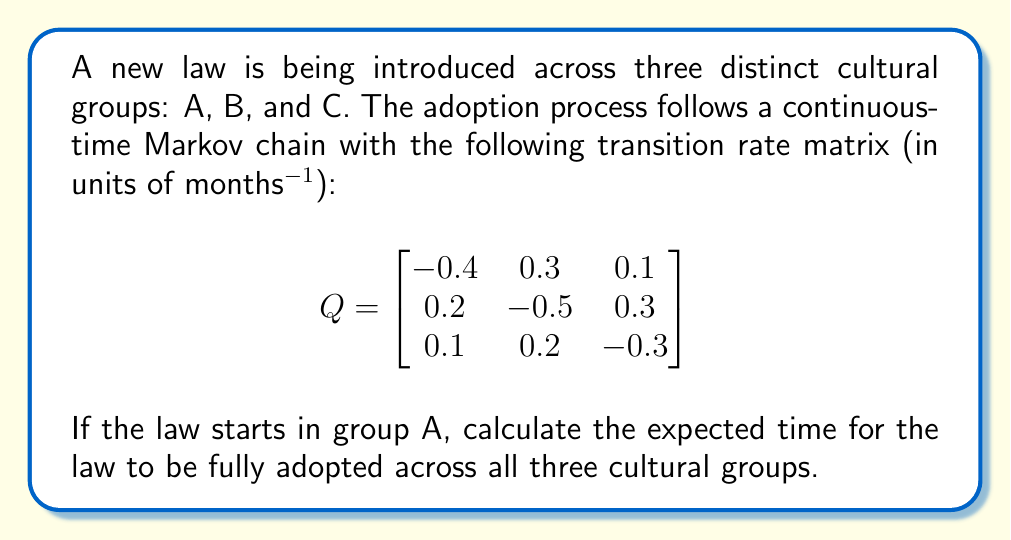Give your solution to this math problem. To solve this problem, we need to use the theory of absorbing Markov chains. The state where the law is fully adopted across all groups is an absorbing state, and we want to find the expected time to reach this state starting from group A.

Step 1: Identify the absorbing state.
The absorbing state is when the law is adopted by all groups, which is not explicitly represented in the given matrix. We need to add this state as a fourth state D.

Step 2: Modify the transition rate matrix to include the absorbing state.
$$Q' = \begin{bmatrix}
-0.4 & 0.3 & 0.1 & 0 \\
0.2 & -0.5 & 0.3 & 0 \\
0.1 & 0.2 & -0.3 & 0 \\
0 & 0 & 0 & 0
\end{bmatrix}$$

Step 3: Partition the matrix into submatrices.
$$Q' = \begin{bmatrix}
T & R \\
0 & 0
\end{bmatrix}$$

Where T is the 3x3 submatrix of transient states, and R is the 3x1 column vector of rates to the absorbing state.

Step 4: Calculate the fundamental matrix N.
$$N = -T^{-1}$$

Using a computer algebra system or matrix inversion method:

$$N = \begin{bmatrix}
3.8462 & 2.6923 & 1.9231 \\
2.3077 & 4.6154 & 2.3077 \\
1.5385 & 2.3077 & 4.6154
\end{bmatrix}$$

Step 5: Calculate the expected time to absorption.
The expected time to absorption starting from state i is given by the sum of the i-th row of N. Since we start in group A (first row):

Expected time = 3.8462 + 2.6923 + 1.9231 = 8.4616 months
Answer: 8.4616 months 